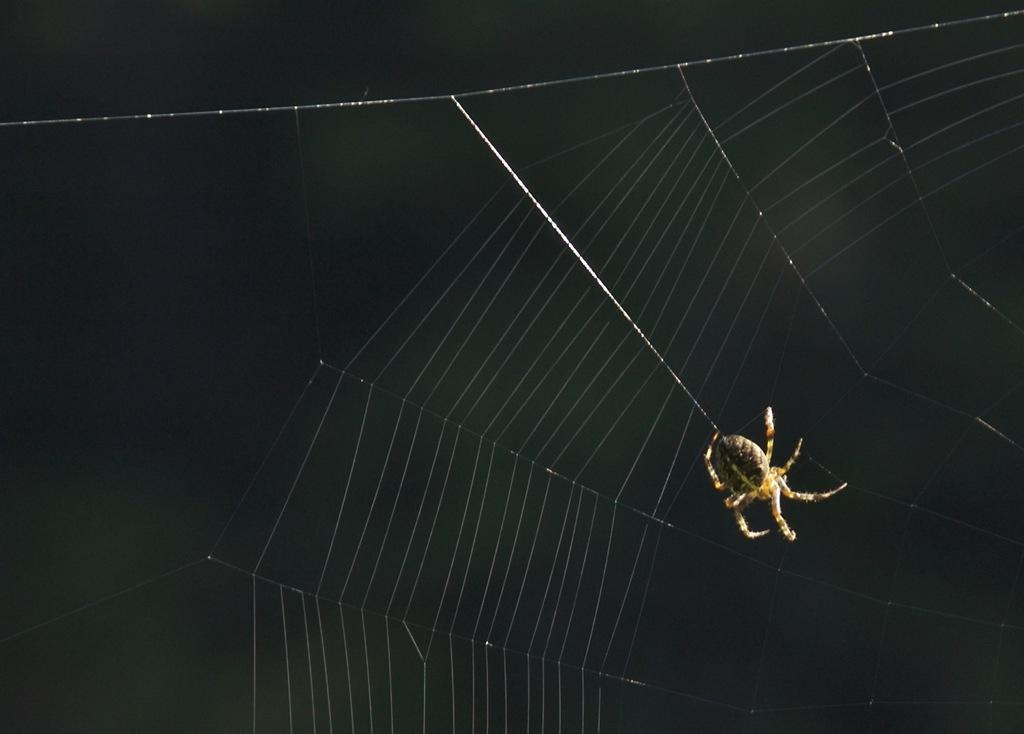What is the main subject of the image? The main subject of the image is a spider. What is the spider doing in the image? The spider is constructing a spider web. What is the color of the background in the image? The background of the image is black in color. What type of unit is being printed on the top of the image? There is no unit or printing present in the image; it features a spider constructing a spider web against a black background. 